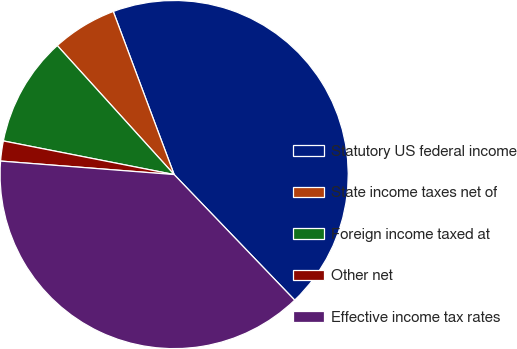Convert chart. <chart><loc_0><loc_0><loc_500><loc_500><pie_chart><fcel>Statutory US federal income<fcel>State income taxes net of<fcel>Foreign income taxed at<fcel>Other net<fcel>Effective income tax rates<nl><fcel>43.51%<fcel>6.03%<fcel>10.19%<fcel>1.86%<fcel>38.41%<nl></chart> 